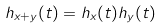Convert formula to latex. <formula><loc_0><loc_0><loc_500><loc_500>h _ { x + y } ( t ) = h _ { x } ( t ) h _ { y } ( t )</formula> 